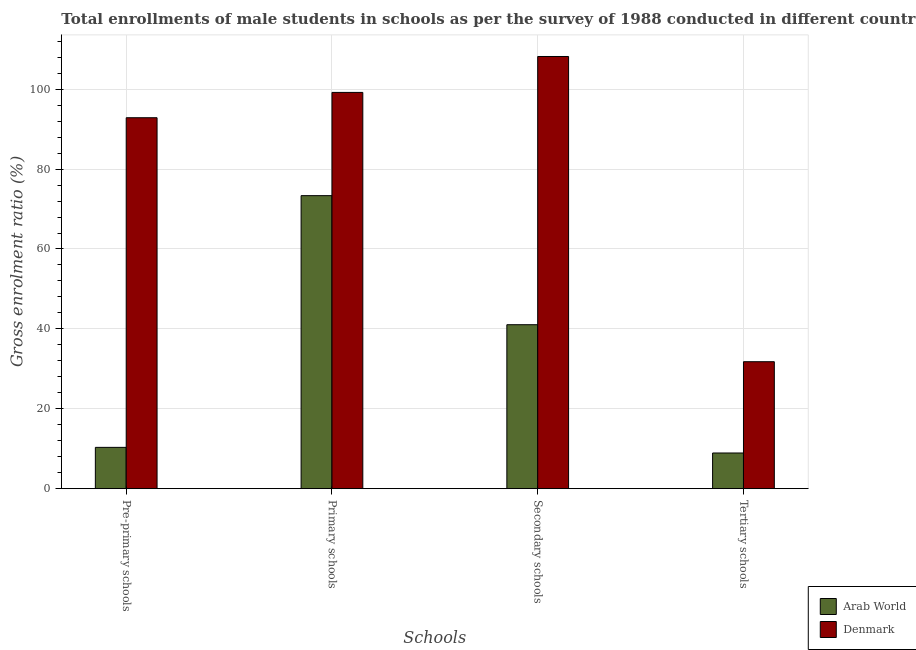What is the label of the 2nd group of bars from the left?
Make the answer very short. Primary schools. What is the gross enrolment ratio(male) in tertiary schools in Arab World?
Your answer should be compact. 8.93. Across all countries, what is the maximum gross enrolment ratio(male) in pre-primary schools?
Your response must be concise. 92.86. Across all countries, what is the minimum gross enrolment ratio(male) in pre-primary schools?
Ensure brevity in your answer.  10.34. In which country was the gross enrolment ratio(male) in secondary schools minimum?
Offer a very short reply. Arab World. What is the total gross enrolment ratio(male) in pre-primary schools in the graph?
Offer a terse response. 103.2. What is the difference between the gross enrolment ratio(male) in primary schools in Denmark and that in Arab World?
Offer a very short reply. 25.84. What is the difference between the gross enrolment ratio(male) in secondary schools in Denmark and the gross enrolment ratio(male) in pre-primary schools in Arab World?
Your answer should be compact. 97.85. What is the average gross enrolment ratio(male) in primary schools per country?
Your answer should be very brief. 86.28. What is the difference between the gross enrolment ratio(male) in secondary schools and gross enrolment ratio(male) in pre-primary schools in Arab World?
Offer a very short reply. 30.71. What is the ratio of the gross enrolment ratio(male) in primary schools in Denmark to that in Arab World?
Give a very brief answer. 1.35. What is the difference between the highest and the second highest gross enrolment ratio(male) in pre-primary schools?
Provide a succinct answer. 82.52. What is the difference between the highest and the lowest gross enrolment ratio(male) in tertiary schools?
Your response must be concise. 22.85. In how many countries, is the gross enrolment ratio(male) in primary schools greater than the average gross enrolment ratio(male) in primary schools taken over all countries?
Provide a succinct answer. 1. Is it the case that in every country, the sum of the gross enrolment ratio(male) in secondary schools and gross enrolment ratio(male) in primary schools is greater than the sum of gross enrolment ratio(male) in pre-primary schools and gross enrolment ratio(male) in tertiary schools?
Offer a terse response. Yes. What does the 1st bar from the left in Primary schools represents?
Give a very brief answer. Arab World. Is it the case that in every country, the sum of the gross enrolment ratio(male) in pre-primary schools and gross enrolment ratio(male) in primary schools is greater than the gross enrolment ratio(male) in secondary schools?
Provide a short and direct response. Yes. How many countries are there in the graph?
Your answer should be very brief. 2. What is the difference between two consecutive major ticks on the Y-axis?
Your answer should be compact. 20. Are the values on the major ticks of Y-axis written in scientific E-notation?
Make the answer very short. No. Does the graph contain any zero values?
Provide a succinct answer. No. Where does the legend appear in the graph?
Provide a succinct answer. Bottom right. What is the title of the graph?
Offer a very short reply. Total enrollments of male students in schools as per the survey of 1988 conducted in different countries. What is the label or title of the X-axis?
Give a very brief answer. Schools. What is the label or title of the Y-axis?
Ensure brevity in your answer.  Gross enrolment ratio (%). What is the Gross enrolment ratio (%) in Arab World in Pre-primary schools?
Make the answer very short. 10.34. What is the Gross enrolment ratio (%) in Denmark in Pre-primary schools?
Keep it short and to the point. 92.86. What is the Gross enrolment ratio (%) in Arab World in Primary schools?
Your answer should be compact. 73.35. What is the Gross enrolment ratio (%) in Denmark in Primary schools?
Your answer should be compact. 99.2. What is the Gross enrolment ratio (%) of Arab World in Secondary schools?
Offer a terse response. 41.05. What is the Gross enrolment ratio (%) of Denmark in Secondary schools?
Give a very brief answer. 108.19. What is the Gross enrolment ratio (%) in Arab World in Tertiary schools?
Your answer should be very brief. 8.93. What is the Gross enrolment ratio (%) of Denmark in Tertiary schools?
Keep it short and to the point. 31.78. Across all Schools, what is the maximum Gross enrolment ratio (%) in Arab World?
Give a very brief answer. 73.35. Across all Schools, what is the maximum Gross enrolment ratio (%) in Denmark?
Make the answer very short. 108.19. Across all Schools, what is the minimum Gross enrolment ratio (%) in Arab World?
Keep it short and to the point. 8.93. Across all Schools, what is the minimum Gross enrolment ratio (%) in Denmark?
Make the answer very short. 31.78. What is the total Gross enrolment ratio (%) in Arab World in the graph?
Your response must be concise. 133.67. What is the total Gross enrolment ratio (%) of Denmark in the graph?
Your answer should be very brief. 332.03. What is the difference between the Gross enrolment ratio (%) in Arab World in Pre-primary schools and that in Primary schools?
Keep it short and to the point. -63.01. What is the difference between the Gross enrolment ratio (%) of Denmark in Pre-primary schools and that in Primary schools?
Give a very brief answer. -6.34. What is the difference between the Gross enrolment ratio (%) in Arab World in Pre-primary schools and that in Secondary schools?
Make the answer very short. -30.71. What is the difference between the Gross enrolment ratio (%) of Denmark in Pre-primary schools and that in Secondary schools?
Your answer should be compact. -15.33. What is the difference between the Gross enrolment ratio (%) in Arab World in Pre-primary schools and that in Tertiary schools?
Keep it short and to the point. 1.41. What is the difference between the Gross enrolment ratio (%) in Denmark in Pre-primary schools and that in Tertiary schools?
Keep it short and to the point. 61.08. What is the difference between the Gross enrolment ratio (%) in Arab World in Primary schools and that in Secondary schools?
Your response must be concise. 32.31. What is the difference between the Gross enrolment ratio (%) of Denmark in Primary schools and that in Secondary schools?
Keep it short and to the point. -8.99. What is the difference between the Gross enrolment ratio (%) of Arab World in Primary schools and that in Tertiary schools?
Provide a succinct answer. 64.42. What is the difference between the Gross enrolment ratio (%) of Denmark in Primary schools and that in Tertiary schools?
Offer a very short reply. 67.42. What is the difference between the Gross enrolment ratio (%) in Arab World in Secondary schools and that in Tertiary schools?
Make the answer very short. 32.11. What is the difference between the Gross enrolment ratio (%) in Denmark in Secondary schools and that in Tertiary schools?
Your response must be concise. 76.41. What is the difference between the Gross enrolment ratio (%) in Arab World in Pre-primary schools and the Gross enrolment ratio (%) in Denmark in Primary schools?
Your response must be concise. -88.86. What is the difference between the Gross enrolment ratio (%) of Arab World in Pre-primary schools and the Gross enrolment ratio (%) of Denmark in Secondary schools?
Offer a very short reply. -97.85. What is the difference between the Gross enrolment ratio (%) in Arab World in Pre-primary schools and the Gross enrolment ratio (%) in Denmark in Tertiary schools?
Your response must be concise. -21.44. What is the difference between the Gross enrolment ratio (%) in Arab World in Primary schools and the Gross enrolment ratio (%) in Denmark in Secondary schools?
Give a very brief answer. -34.84. What is the difference between the Gross enrolment ratio (%) of Arab World in Primary schools and the Gross enrolment ratio (%) of Denmark in Tertiary schools?
Provide a short and direct response. 41.57. What is the difference between the Gross enrolment ratio (%) of Arab World in Secondary schools and the Gross enrolment ratio (%) of Denmark in Tertiary schools?
Your response must be concise. 9.26. What is the average Gross enrolment ratio (%) in Arab World per Schools?
Give a very brief answer. 33.42. What is the average Gross enrolment ratio (%) of Denmark per Schools?
Give a very brief answer. 83.01. What is the difference between the Gross enrolment ratio (%) in Arab World and Gross enrolment ratio (%) in Denmark in Pre-primary schools?
Ensure brevity in your answer.  -82.52. What is the difference between the Gross enrolment ratio (%) of Arab World and Gross enrolment ratio (%) of Denmark in Primary schools?
Provide a short and direct response. -25.84. What is the difference between the Gross enrolment ratio (%) in Arab World and Gross enrolment ratio (%) in Denmark in Secondary schools?
Your response must be concise. -67.14. What is the difference between the Gross enrolment ratio (%) of Arab World and Gross enrolment ratio (%) of Denmark in Tertiary schools?
Your answer should be compact. -22.85. What is the ratio of the Gross enrolment ratio (%) in Arab World in Pre-primary schools to that in Primary schools?
Your response must be concise. 0.14. What is the ratio of the Gross enrolment ratio (%) in Denmark in Pre-primary schools to that in Primary schools?
Make the answer very short. 0.94. What is the ratio of the Gross enrolment ratio (%) in Arab World in Pre-primary schools to that in Secondary schools?
Offer a very short reply. 0.25. What is the ratio of the Gross enrolment ratio (%) of Denmark in Pre-primary schools to that in Secondary schools?
Your answer should be very brief. 0.86. What is the ratio of the Gross enrolment ratio (%) in Arab World in Pre-primary schools to that in Tertiary schools?
Your response must be concise. 1.16. What is the ratio of the Gross enrolment ratio (%) of Denmark in Pre-primary schools to that in Tertiary schools?
Your answer should be very brief. 2.92. What is the ratio of the Gross enrolment ratio (%) in Arab World in Primary schools to that in Secondary schools?
Offer a very short reply. 1.79. What is the ratio of the Gross enrolment ratio (%) of Denmark in Primary schools to that in Secondary schools?
Offer a terse response. 0.92. What is the ratio of the Gross enrolment ratio (%) of Arab World in Primary schools to that in Tertiary schools?
Ensure brevity in your answer.  8.21. What is the ratio of the Gross enrolment ratio (%) of Denmark in Primary schools to that in Tertiary schools?
Ensure brevity in your answer.  3.12. What is the ratio of the Gross enrolment ratio (%) of Arab World in Secondary schools to that in Tertiary schools?
Give a very brief answer. 4.59. What is the ratio of the Gross enrolment ratio (%) of Denmark in Secondary schools to that in Tertiary schools?
Offer a very short reply. 3.4. What is the difference between the highest and the second highest Gross enrolment ratio (%) of Arab World?
Your answer should be compact. 32.31. What is the difference between the highest and the second highest Gross enrolment ratio (%) of Denmark?
Give a very brief answer. 8.99. What is the difference between the highest and the lowest Gross enrolment ratio (%) of Arab World?
Provide a succinct answer. 64.42. What is the difference between the highest and the lowest Gross enrolment ratio (%) in Denmark?
Provide a succinct answer. 76.41. 